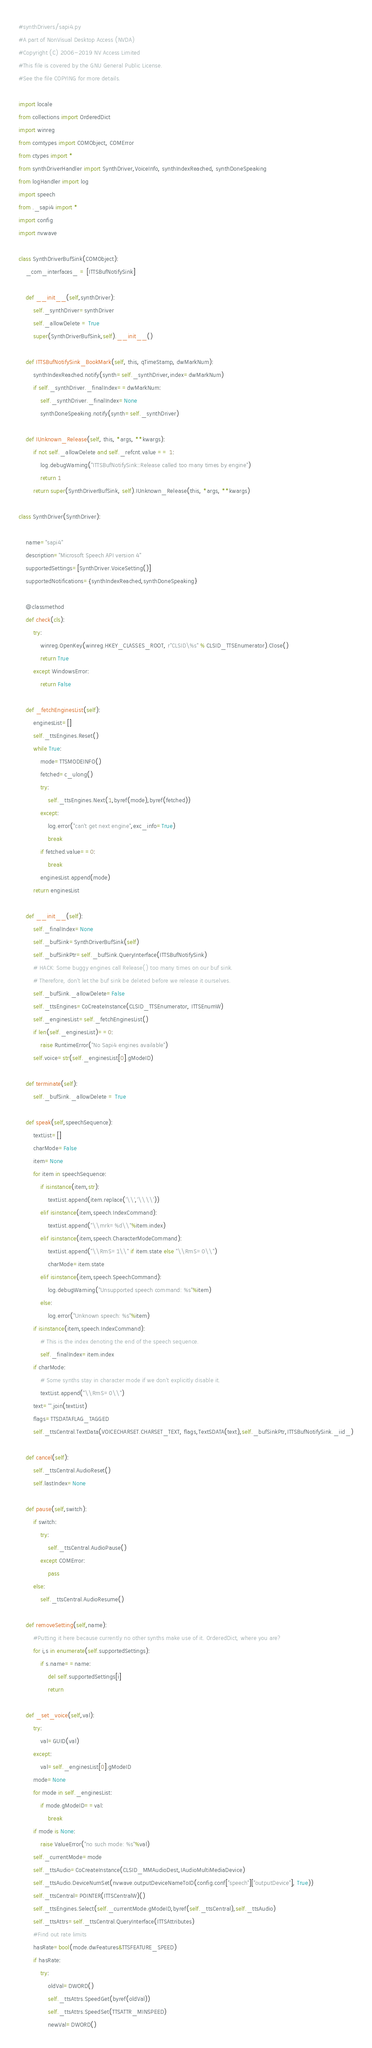Convert code to text. <code><loc_0><loc_0><loc_500><loc_500><_Python_>#synthDrivers/sapi4.py
#A part of NonVisual Desktop Access (NVDA)
#Copyright (C) 2006-2019 NV Access Limited 
#This file is covered by the GNU General Public License.
#See the file COPYING for more details.

import locale
from collections import OrderedDict
import winreg
from comtypes import COMObject, COMError
from ctypes import *
from synthDriverHandler import SynthDriver,VoiceInfo, synthIndexReached, synthDoneSpeaking
from logHandler import log
import speech
from ._sapi4 import *
import config
import nvwave

class SynthDriverBufSink(COMObject):
	_com_interfaces_ = [ITTSBufNotifySink]

	def __init__(self,synthDriver):
		self._synthDriver=synthDriver
		self._allowDelete = True
		super(SynthDriverBufSink,self).__init__()

	def ITTSBufNotifySink_BookMark(self, this, qTimeStamp, dwMarkNum):
		synthIndexReached.notify(synth=self._synthDriver,index=dwMarkNum)
		if self._synthDriver._finalIndex==dwMarkNum:
			self._synthDriver._finalIndex=None
			synthDoneSpeaking.notify(synth=self._synthDriver)

	def IUnknown_Release(self, this, *args, **kwargs):
		if not self._allowDelete and self._refcnt.value == 1:
			log.debugWarning("ITTSBufNotifySink::Release called too many times by engine")
			return 1
		return super(SynthDriverBufSink, self).IUnknown_Release(this, *args, **kwargs)

class SynthDriver(SynthDriver):

	name="sapi4"
	description="Microsoft Speech API version 4"
	supportedSettings=[SynthDriver.VoiceSetting()]
	supportedNotifications={synthIndexReached,synthDoneSpeaking}

	@classmethod
	def check(cls):
		try:
			winreg.OpenKey(winreg.HKEY_CLASSES_ROOT, r"CLSID\%s" % CLSID_TTSEnumerator).Close()
			return True
		except WindowsError:
			return False

	def _fetchEnginesList(self):
		enginesList=[]
		self._ttsEngines.Reset()
		while True:
			mode=TTSMODEINFO()
			fetched=c_ulong()
			try:
				self._ttsEngines.Next(1,byref(mode),byref(fetched))
			except:
				log.error("can't get next engine",exc_info=True)
				break
			if fetched.value==0:
				break
			enginesList.append(mode)
		return enginesList

	def __init__(self):
		self._finalIndex=None
		self._bufSink=SynthDriverBufSink(self)
		self._bufSinkPtr=self._bufSink.QueryInterface(ITTSBufNotifySink)
		# HACK: Some buggy engines call Release() too many times on our buf sink.
		# Therefore, don't let the buf sink be deleted before we release it ourselves.
		self._bufSink._allowDelete=False
		self._ttsEngines=CoCreateInstance(CLSID_TTSEnumerator, ITTSEnumW)
		self._enginesList=self._fetchEnginesList()
		if len(self._enginesList)==0:
			raise RuntimeError("No Sapi4 engines available")
		self.voice=str(self._enginesList[0].gModeID)

	def terminate(self):
		self._bufSink._allowDelete = True

	def speak(self,speechSequence):
		textList=[]
		charMode=False
		item=None
		for item in speechSequence:
			if isinstance(item,str):
				textList.append(item.replace('\\','\\\\'))
			elif isinstance(item,speech.IndexCommand):
				textList.append("\\mrk=%d\\"%item.index)
			elif isinstance(item,speech.CharacterModeCommand):
				textList.append("\\RmS=1\\" if item.state else "\\RmS=0\\")
				charMode=item.state
			elif isinstance(item,speech.SpeechCommand):
				log.debugWarning("Unsupported speech command: %s"%item)
			else:
				log.error("Unknown speech: %s"%item)
		if isinstance(item,speech.IndexCommand):
			# This is the index denoting the end of the speech sequence.
			self._finalIndex=item.index
		if charMode:
			# Some synths stay in character mode if we don't explicitly disable it.
			textList.append("\\RmS=0\\")
		text="".join(textList)
		flags=TTSDATAFLAG_TAGGED
		self._ttsCentral.TextData(VOICECHARSET.CHARSET_TEXT, flags,TextSDATA(text),self._bufSinkPtr,ITTSBufNotifySink._iid_)

	def cancel(self):
		self._ttsCentral.AudioReset()
		self.lastIndex=None

	def pause(self,switch):
		if switch:
			try:
				self._ttsCentral.AudioPause()
			except COMError:
				pass
		else:
			self._ttsCentral.AudioResume()

	def removeSetting(self,name):
		#Putting it here because currently no other synths make use of it. OrderedDict, where you are?
		for i,s in enumerate(self.supportedSettings):
			if s.name==name:
				del self.supportedSettings[i]
				return

	def _set_voice(self,val):
		try:
			val=GUID(val)
		except:
			val=self._enginesList[0].gModeID
		mode=None
		for mode in self._enginesList:
			if mode.gModeID==val:
				break
		if mode is None:
			raise ValueError("no such mode: %s"%val)
		self._currentMode=mode
		self._ttsAudio=CoCreateInstance(CLSID_MMAudioDest,IAudioMultiMediaDevice)
		self._ttsAudio.DeviceNumSet(nvwave.outputDeviceNameToID(config.conf["speech"]["outputDevice"], True))
		self._ttsCentral=POINTER(ITTSCentralW)()
		self._ttsEngines.Select(self._currentMode.gModeID,byref(self._ttsCentral),self._ttsAudio)
		self._ttsAttrs=self._ttsCentral.QueryInterface(ITTSAttributes)
		#Find out rate limits
		hasRate=bool(mode.dwFeatures&TTSFEATURE_SPEED)
		if hasRate:
			try:
				oldVal=DWORD()
				self._ttsAttrs.SpeedGet(byref(oldVal))
				self._ttsAttrs.SpeedSet(TTSATTR_MINSPEED)
				newVal=DWORD()</code> 